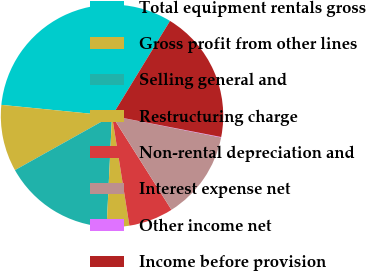<chart> <loc_0><loc_0><loc_500><loc_500><pie_chart><fcel>Total equipment rentals gross<fcel>Gross profit from other lines<fcel>Selling general and<fcel>Restructuring charge<fcel>Non-rental depreciation and<fcel>Interest expense net<fcel>Other income net<fcel>Income before provision<nl><fcel>32.16%<fcel>9.69%<fcel>16.11%<fcel>3.27%<fcel>6.48%<fcel>12.9%<fcel>0.07%<fcel>19.32%<nl></chart> 